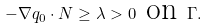Convert formula to latex. <formula><loc_0><loc_0><loc_500><loc_500>- \nabla q _ { 0 } \cdot N \geq \lambda > 0 \text { on } \Gamma .</formula> 